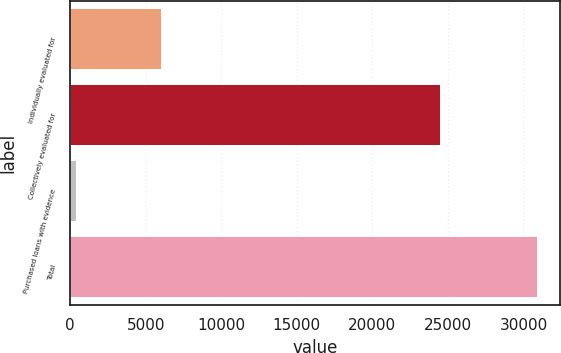<chart> <loc_0><loc_0><loc_500><loc_500><bar_chart><fcel>Individually evaluated for<fcel>Collectively evaluated for<fcel>Purchased loans with evidence<fcel>Total<nl><fcel>5995<fcel>24483<fcel>397<fcel>30875<nl></chart> 